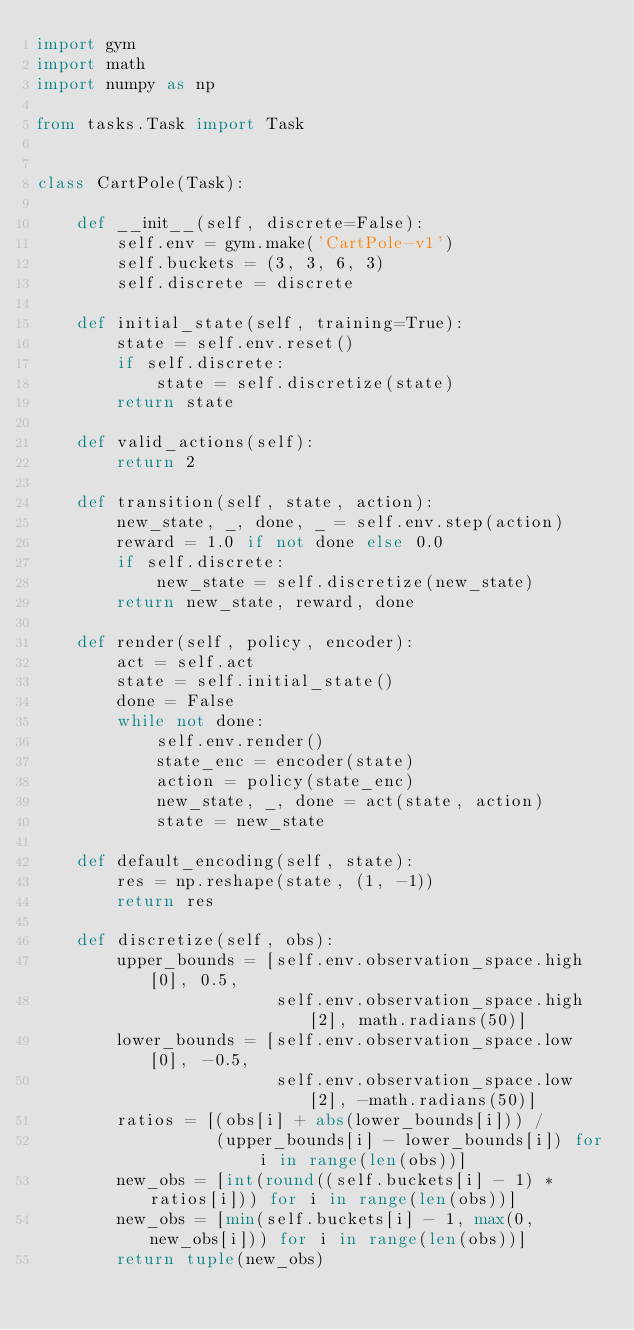<code> <loc_0><loc_0><loc_500><loc_500><_Python_>import gym
import math
import numpy as np

from tasks.Task import Task


class CartPole(Task):

    def __init__(self, discrete=False):
        self.env = gym.make('CartPole-v1')
        self.buckets = (3, 3, 6, 3)
        self.discrete = discrete

    def initial_state(self, training=True):
        state = self.env.reset()
        if self.discrete:
            state = self.discretize(state)
        return state

    def valid_actions(self):
        return 2

    def transition(self, state, action):
        new_state, _, done, _ = self.env.step(action)
        reward = 1.0 if not done else 0.0
        if self.discrete:
            new_state = self.discretize(new_state)
        return new_state, reward, done

    def render(self, policy, encoder):
        act = self.act
        state = self.initial_state()
        done = False
        while not done:
            self.env.render()
            state_enc = encoder(state)
            action = policy(state_enc)
            new_state, _, done = act(state, action)
            state = new_state

    def default_encoding(self, state):
        res = np.reshape(state, (1, -1))
        return res

    def discretize(self, obs):
        upper_bounds = [self.env.observation_space.high[0], 0.5,
                        self.env.observation_space.high[2], math.radians(50)]
        lower_bounds = [self.env.observation_space.low[0], -0.5,
                        self.env.observation_space.low[2], -math.radians(50)]
        ratios = [(obs[i] + abs(lower_bounds[i])) / 
                  (upper_bounds[i] - lower_bounds[i]) for i in range(len(obs))]
        new_obs = [int(round((self.buckets[i] - 1) * ratios[i])) for i in range(len(obs))]
        new_obs = [min(self.buckets[i] - 1, max(0, new_obs[i])) for i in range(len(obs))]
        return tuple(new_obs)
</code> 